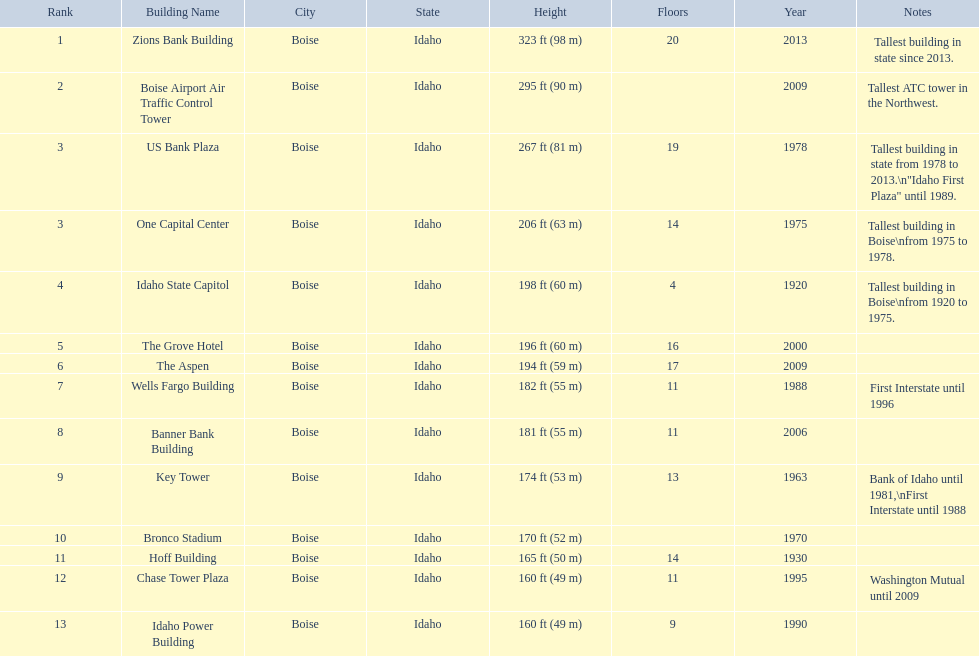What is the name of the building listed after idaho state capitol? The Grove Hotel. 